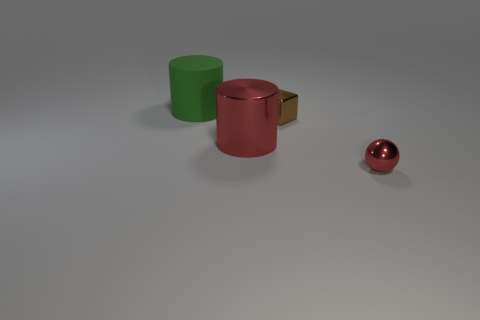Add 4 metal things. How many objects exist? 8 Subtract all red spheres. Subtract all green rubber cylinders. How many objects are left? 2 Add 3 shiny things. How many shiny things are left? 6 Add 1 big cyan metal cylinders. How many big cyan metal cylinders exist? 1 Subtract 0 cyan balls. How many objects are left? 4 Subtract all spheres. How many objects are left? 3 